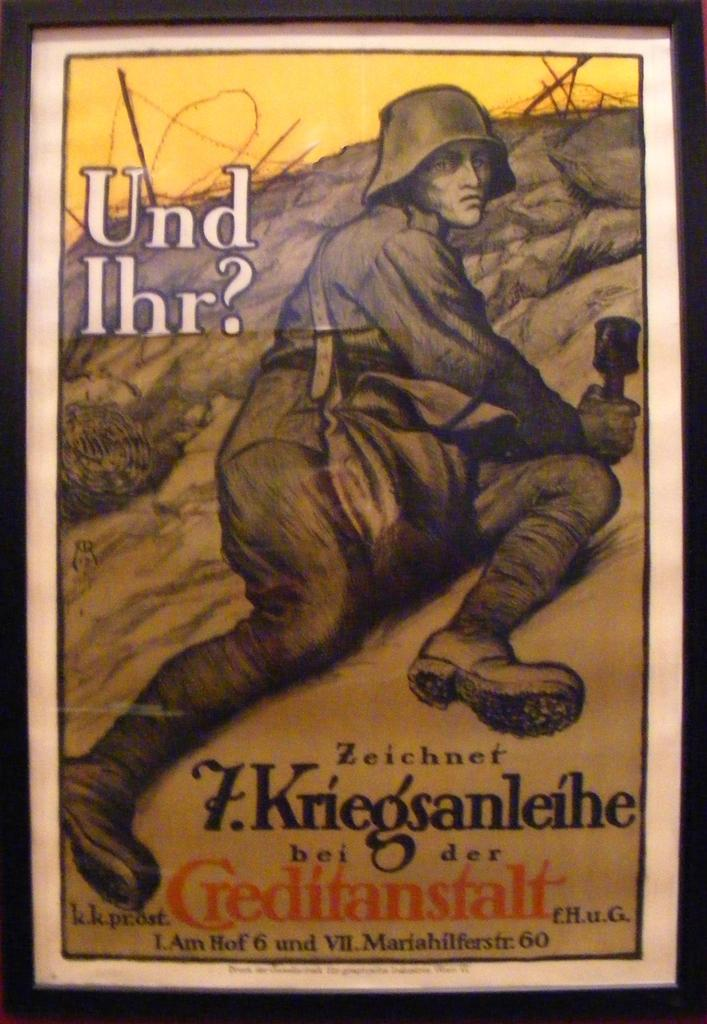<image>
Provide a brief description of the given image. Poster with the word "T.Kriegsanleihe" showing a soldier looking wounded. 